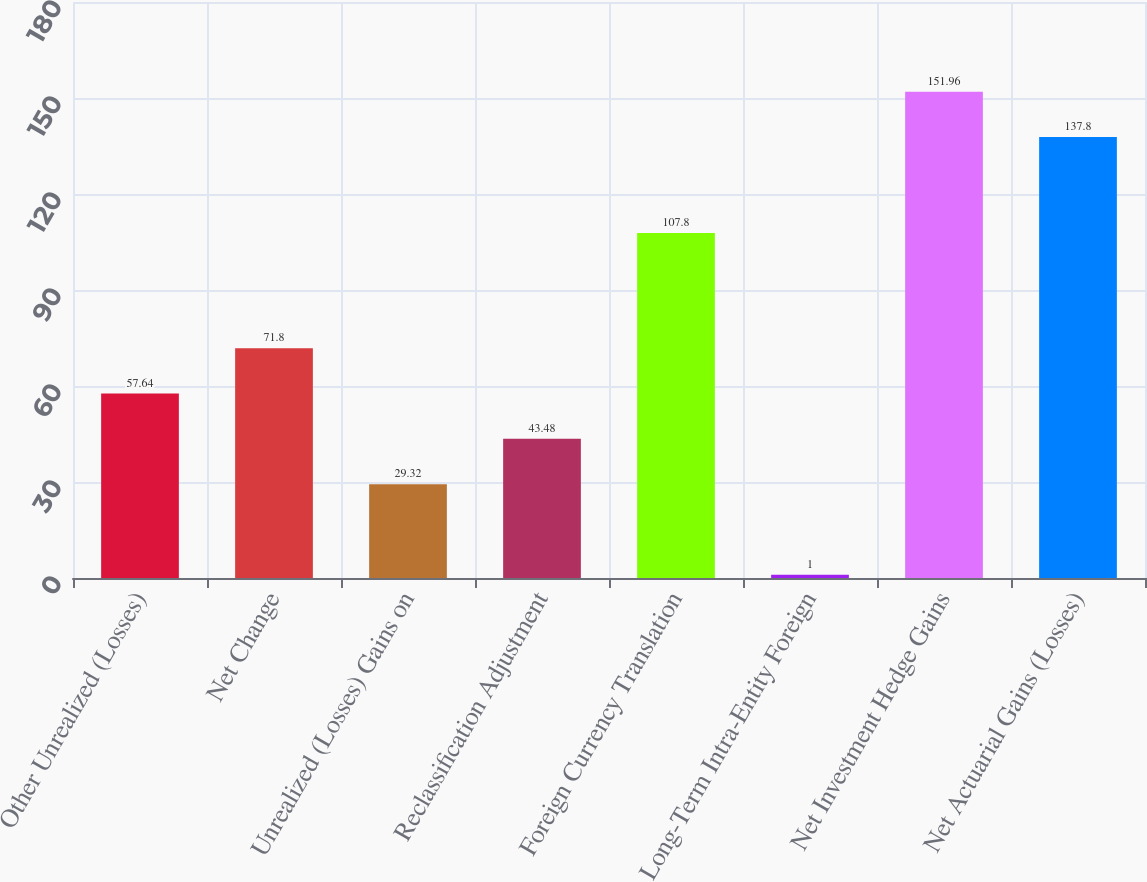Convert chart to OTSL. <chart><loc_0><loc_0><loc_500><loc_500><bar_chart><fcel>Other Unrealized (Losses)<fcel>Net Change<fcel>Unrealized (Losses) Gains on<fcel>Reclassification Adjustment<fcel>Foreign Currency Translation<fcel>Long-Term Intra-Entity Foreign<fcel>Net Investment Hedge Gains<fcel>Net Actuarial Gains (Losses)<nl><fcel>57.64<fcel>71.8<fcel>29.32<fcel>43.48<fcel>107.8<fcel>1<fcel>151.96<fcel>137.8<nl></chart> 